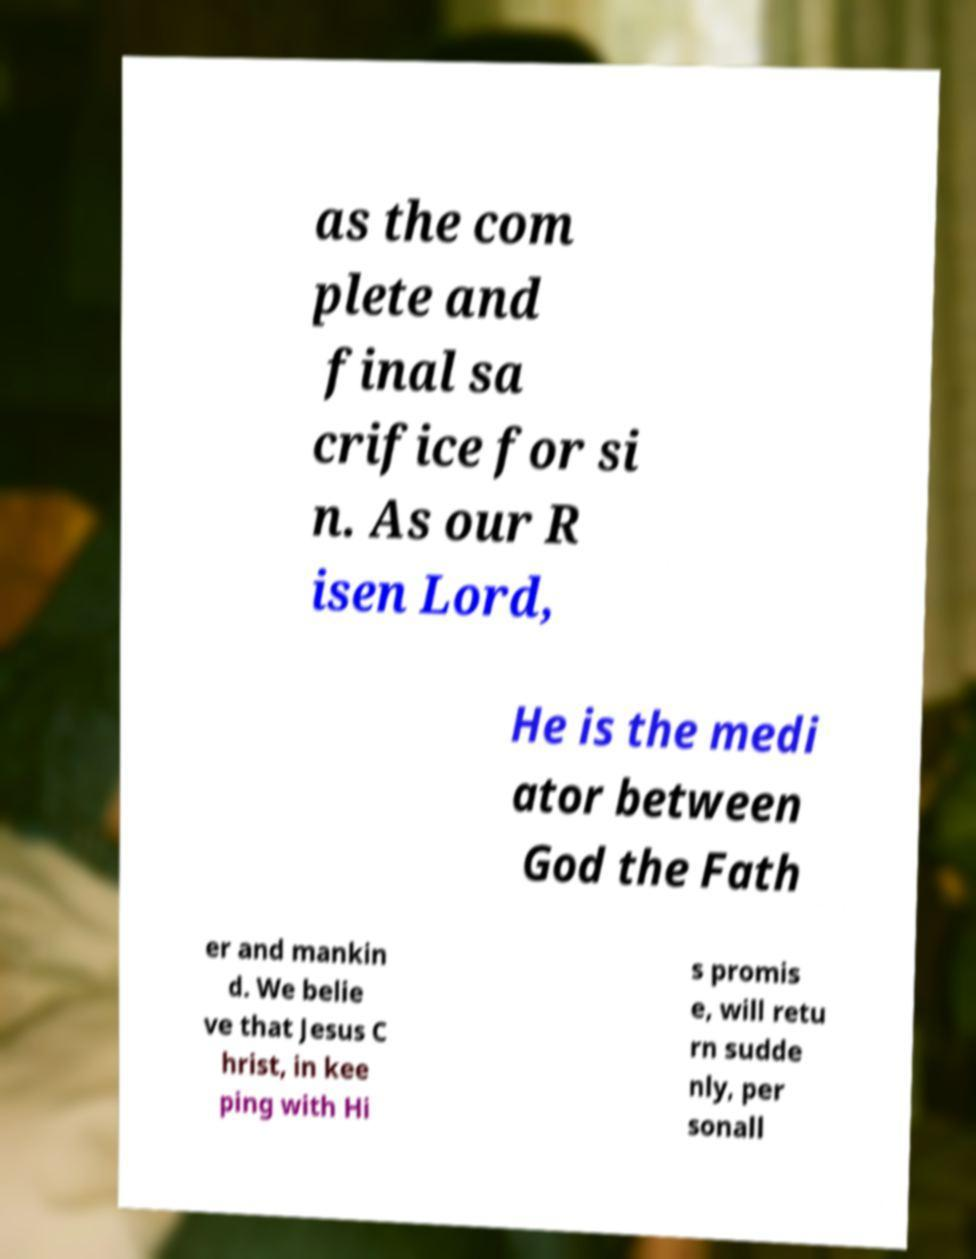Can you read and provide the text displayed in the image?This photo seems to have some interesting text. Can you extract and type it out for me? as the com plete and final sa crifice for si n. As our R isen Lord, He is the medi ator between God the Fath er and mankin d. We belie ve that Jesus C hrist, in kee ping with Hi s promis e, will retu rn sudde nly, per sonall 